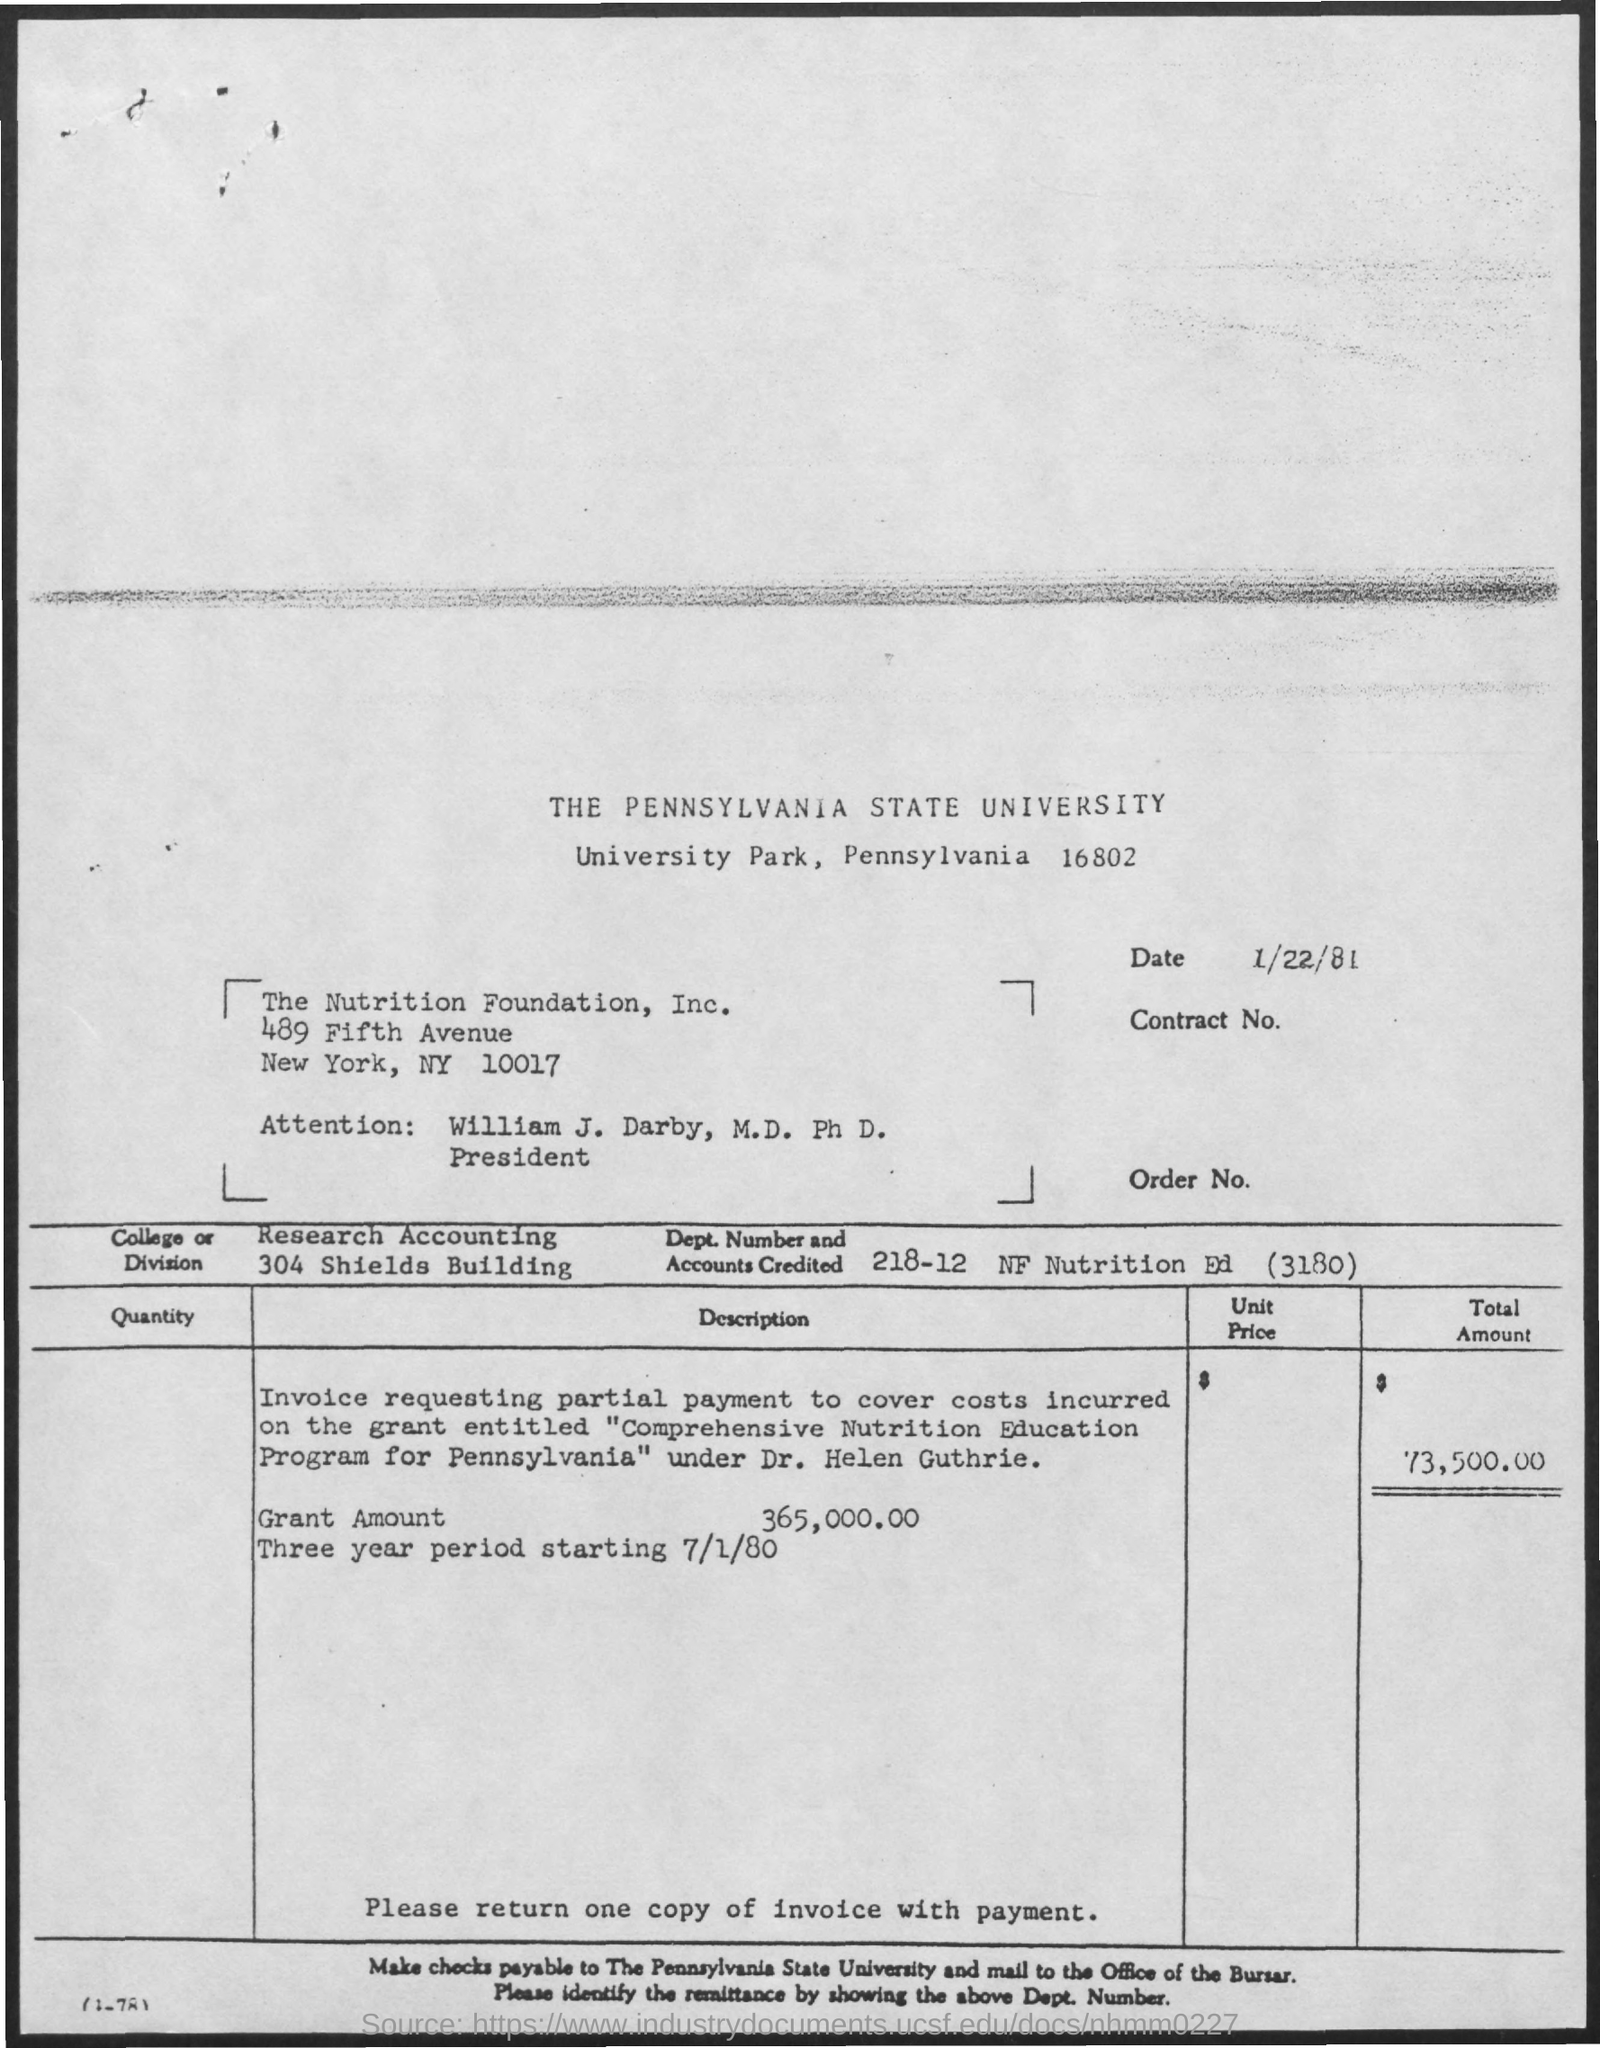List a handful of essential elements in this visual. The grant amount is $365,000.00. The date above the contract number is January 22, 1981. The Pennsylvania State University is the title of the document. The total amount is 73,500.00. 